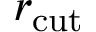<formula> <loc_0><loc_0><loc_500><loc_500>r _ { c u t }</formula> 